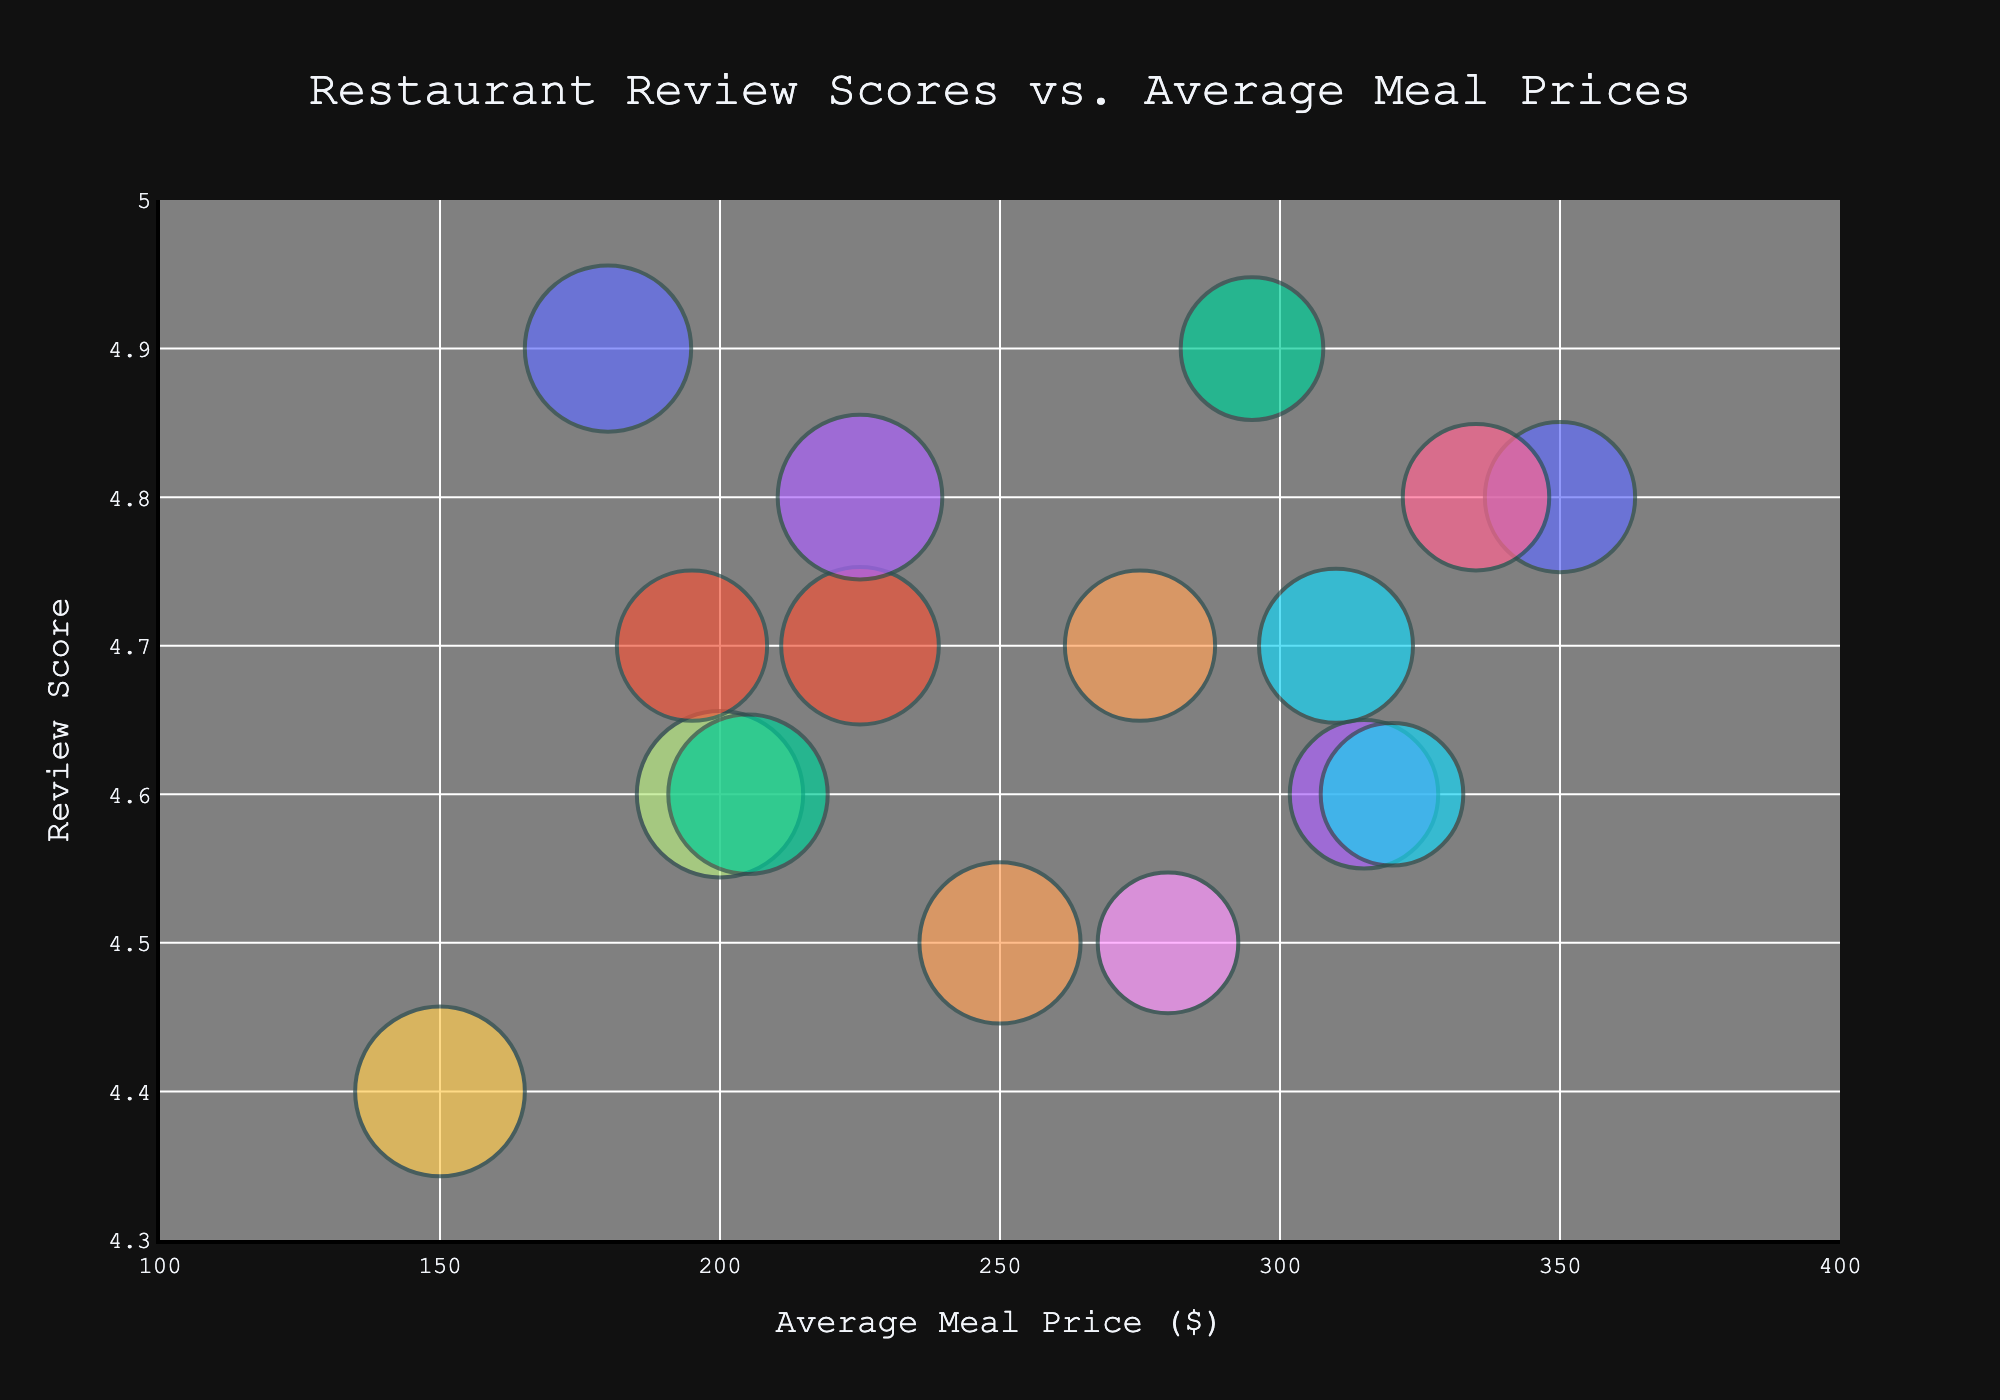What is the title of the figure? The title is usually displayed at the top of the figure. In this case, it reads "Restaurant Review Scores vs. Average Meal Prices".
Answer: Restaurant Review Scores vs. Average Meal Prices What is the range of the x-axis? The range of the x-axis can be determined by looking at the minimum and maximum values shown along the horizontal axis. It ranges from 100 to 400.
Answer: 100 to 400 Which restaurant has the highest review score? To find the restaurant with the highest review score, look for the bubble that is positioned at the top of the chart. "Alinea" and "Gaggan" both have a review score of 4.9, but we should pick one based on size or position.
Answer: Alinea or Gaggan What is the average meal price for "Steirereck"? Locate the bubble labeled "Steirereck" and refer to its position on the x-axis to identify its average meal price. The meal price is approximately 150.
Answer: 150 Which restaurant has the largest bubble, and what does it represent? The largest bubble can be identified by comparing the sizes of the bubbles. “Steirereck” has the largest bubble, which represents diner frequency, specifically 255.
Answer: Steirereck, 255 Which restaurant has the lowest review score and what is its average meal price? Find the bubble located lowest on the y-axis for the lowest review score. "Steirereck" is at a score of 4.4 and has an average meal price of 150.
Answer: Steirereck, 150 How many restaurants have an average meal price above $300? Count the number of bubbles whose positions on the x-axis are greater than 300. There are three such restaurants: "The French Laundry," "Eleven Madison Park," and "Mirazur."
Answer: Three Compare the diner frequencies of "Den" and "Quintonil." Look at the sizes of the bubbles for "Den" and "Quintonil," as the size indicates diner frequency. "Den" has a frequency of 245, whereas "Quintonil" has a frequency of 225.
Answer: Den > Quintonil What is the correlation between average meal prices and review scores shown in the figure? To determine the correlation, observe whether a pattern or trend exists as you move from left to right. There is no clear positive or negative trend indicating that review scores do not strongly correlate with average meal prices in this chart.
Answer: No clear correlation Which restaurant with a review score of 4.7 has the highest average meal price? Identify the bubbles on the y-axis at the 4.7 mark and compare their positions on the x-axis. "Per Se" has the highest average meal price of 310 among those restaurants.
Answer: Per Se, 310 